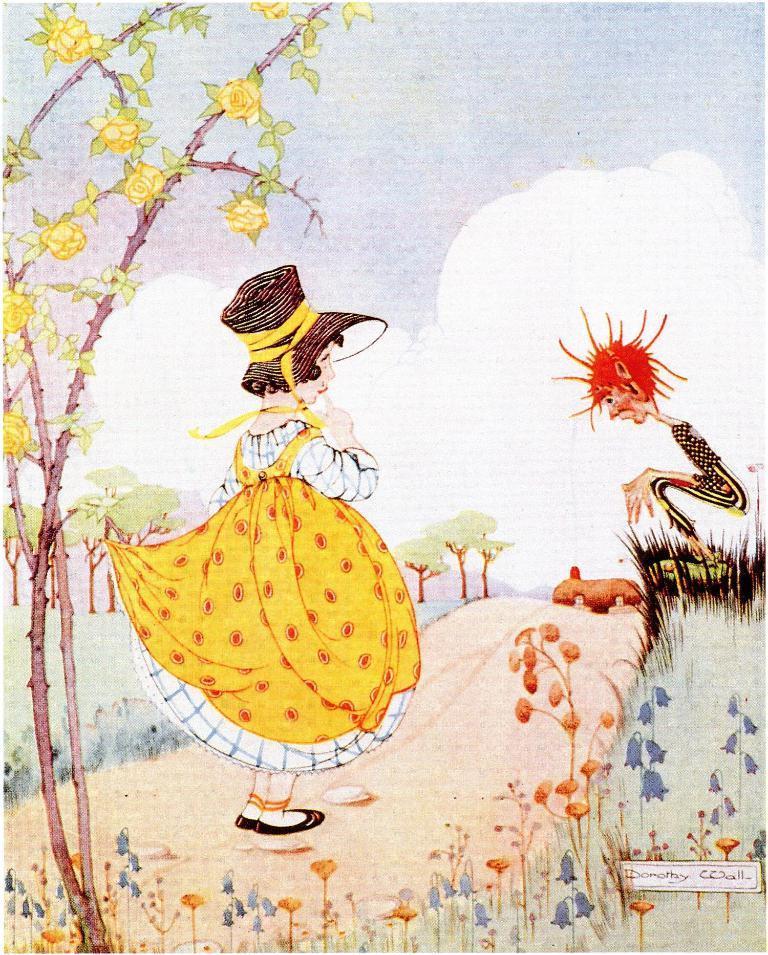Please provide a concise description of this image. Here in this picture we can see a drawing made on a thing and in that we can see two persons present and we can see plants and trees present and we can see clouds in the sky and we can see the whole thing is colored. 